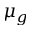Convert formula to latex. <formula><loc_0><loc_0><loc_500><loc_500>\mu _ { g }</formula> 